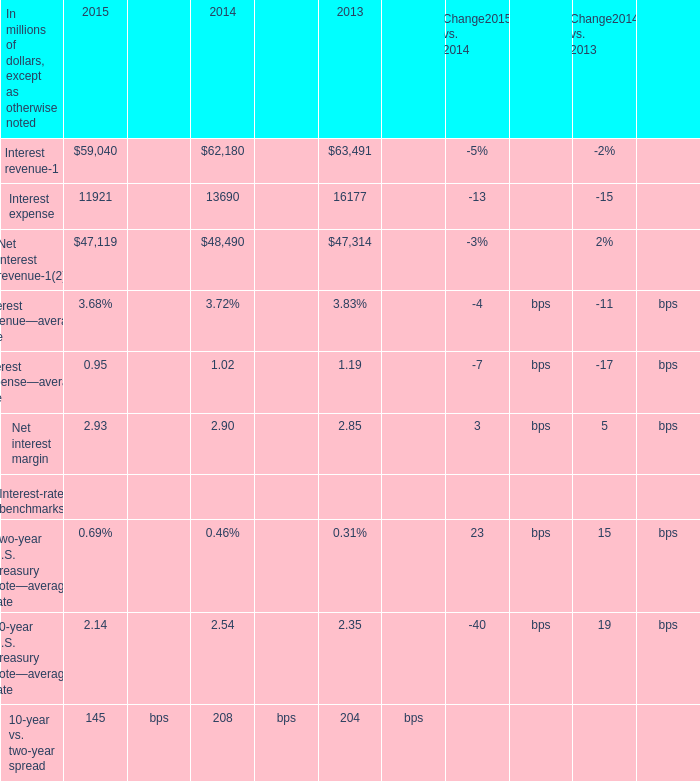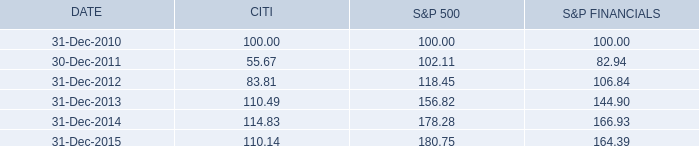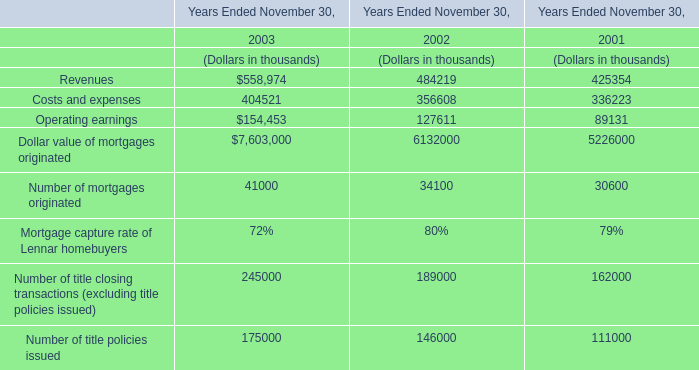what is the highest total amount of Net interest margin? (in bps) 
Answer: 2.93. 